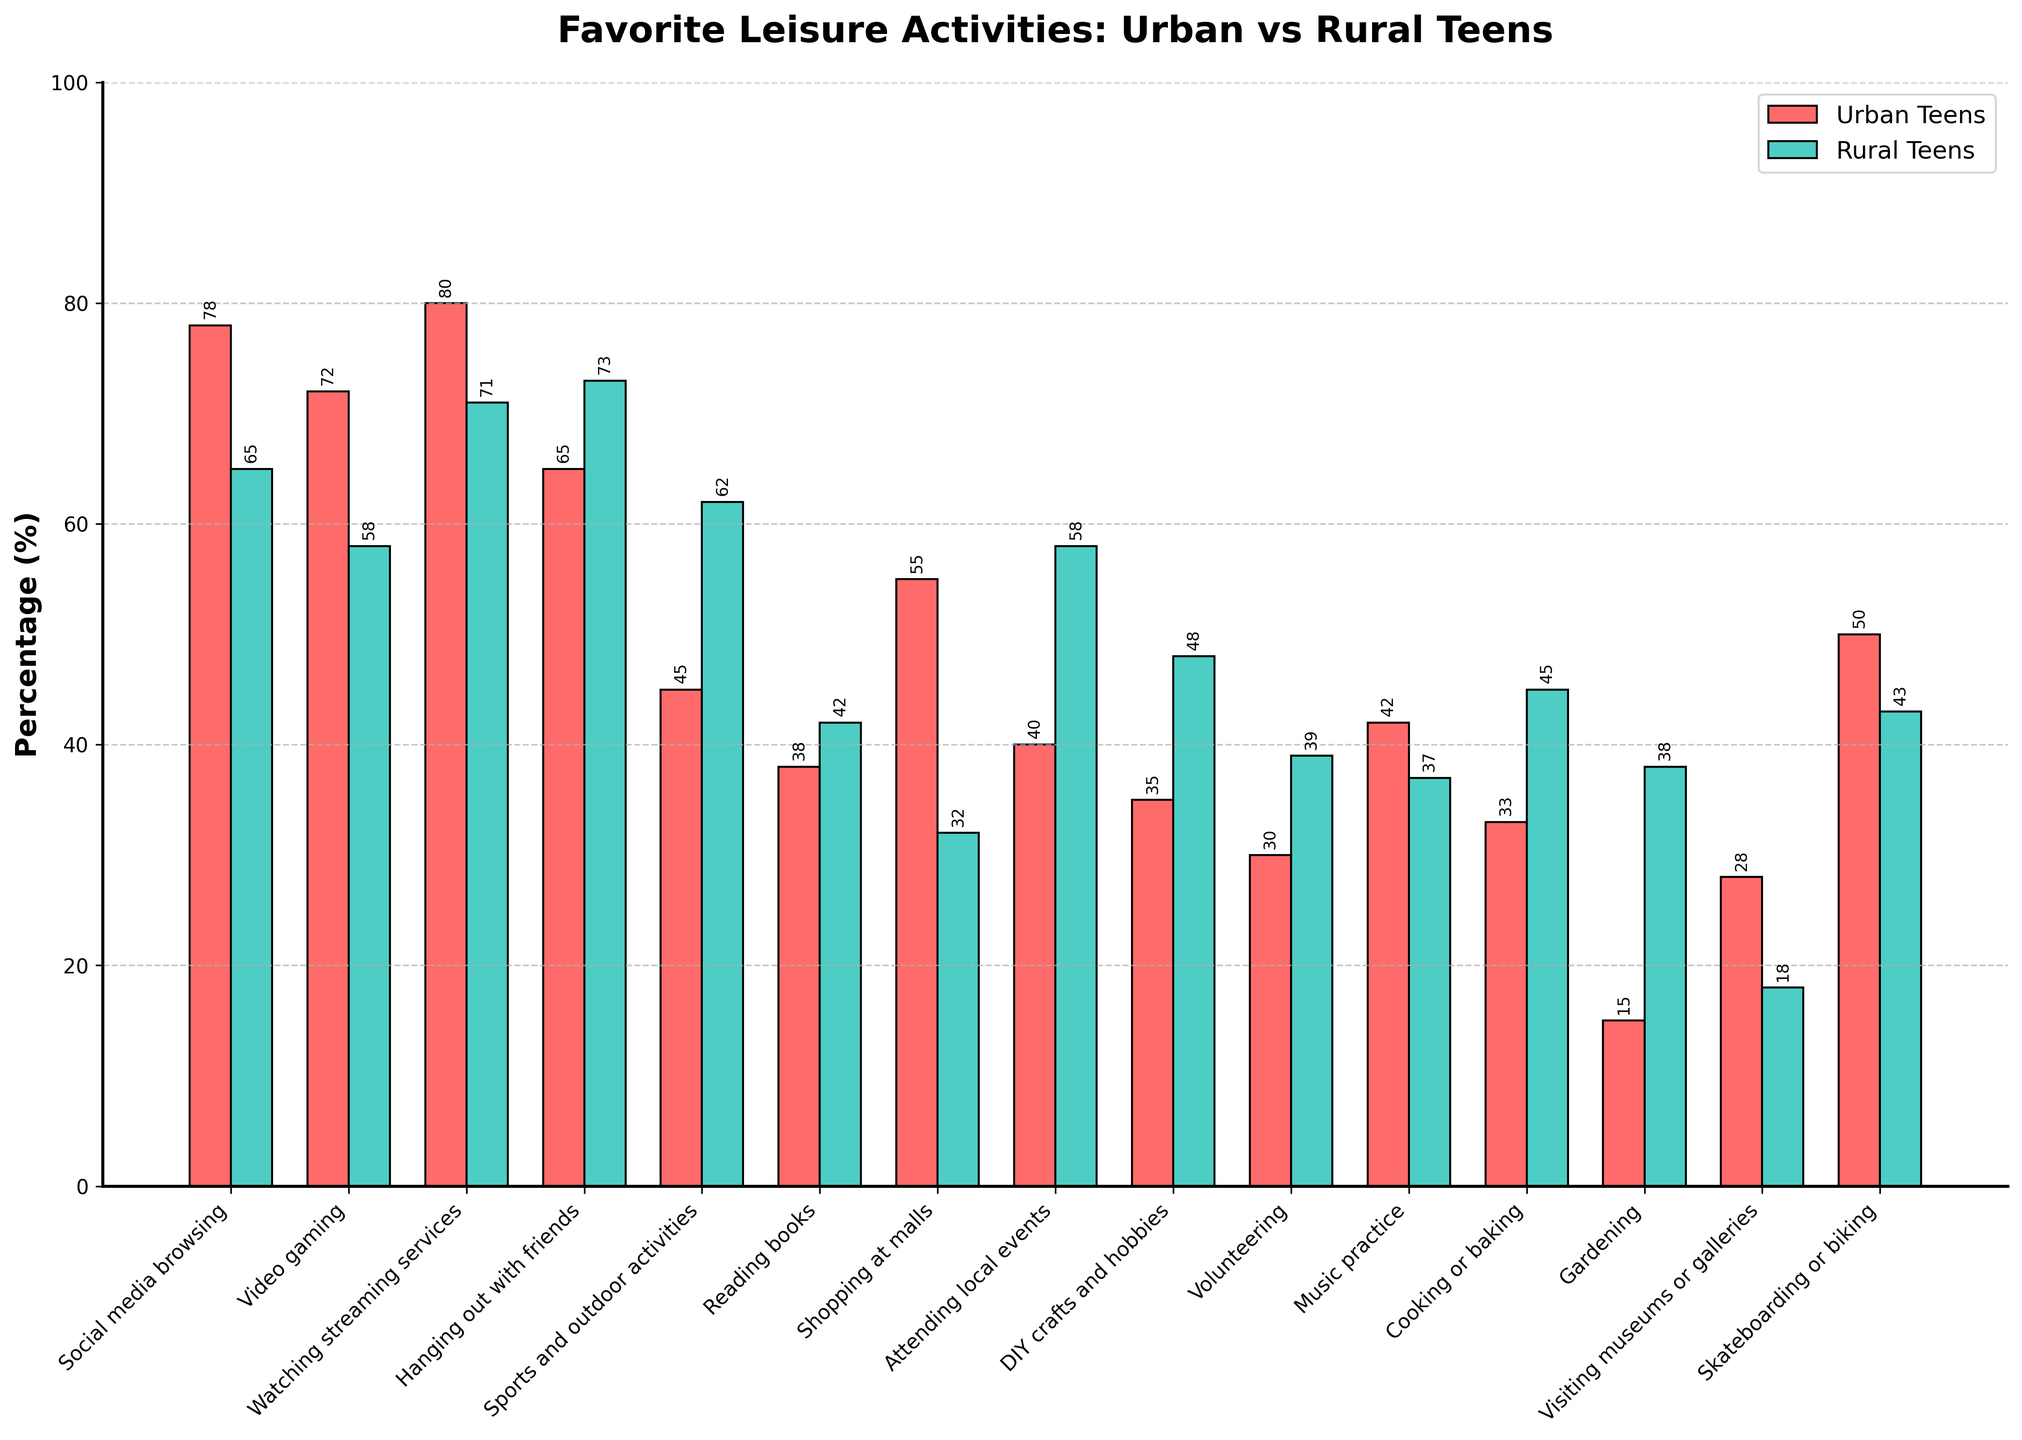Which activity has the highest percentage of urban teens participating? The highest bar representing urban teens is for "Watching streaming services" at 80%.
Answer: Watching streaming services Which activity has the largest difference in participation between urban and rural teens? The activity with the largest difference is "Shopping at malls" where urban teens are at 55% and rural teens at 32%, a difference of 23 percentage points.
Answer: Shopping at malls Which activities are more popular among rural teens than urban teens? By visual comparison, the activities more popular among rural teens than urban teens are: Hanging out with friends, Sports and outdoor activities, Reading books, Attending local events, DIY crafts and hobbies, Volunteering, Cooking or baking, Gardening.
Answer: Hanging out with friends, Sports and outdoor activities, Reading books, Attending local events, DIY crafts and hobbies, Volunteering, Cooking or baking, Gardening Which activity shows the least interest among urban teens? The smallest bar for urban teens is "Gardening" with a percentage of 15%.
Answer: Gardening What is the combined participation percentage of urban teens for "DIY crafts and hobbies" and "Music practice"? The participation percentages are 35% for "DIY crafts and hobbies" and 42% for "Music practice", combining them we get 35 + 42 = 77%.
Answer: 77% For which activity do rural teens have the highest participation? The tallest bar for rural teens is "Hanging out with friends" at 73%.
Answer: Hanging out with friends Are there any activities where the participation percentage is exactly equal for both urban and rural teens? By comparing the bar heights, there are no activities where the participation percentages are exactly equal between urban and rural teens.
Answer: No Which activity has a higher rural teen participation rate by more than 20 percentage points compared to urban teens? "Gardening" has a rural participation rate of 38% and an urban participation rate of 15%. The difference is 38 - 15 = 23 percentage points.
Answer: Gardening What is the average participation rate of urban teens for "Sports and outdoor activities" and "Cooking or baking"? The participation rates are 45% for "Sports and outdoor activities" and 33% for "Cooking or baking". The average is (45 + 33) / 2 = 39%.
Answer: 39% Is there a significant difference in the participation rate of "Volunteering" between urban and rural teens? Urban teens have a participation rate of 30% in "Volunteering", while rural teens have 39%. The difference is 39 - 30 = 9 percentage points, which can be considered moderate.
Answer: Moderate differences of 9% 